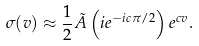Convert formula to latex. <formula><loc_0><loc_0><loc_500><loc_500>\sigma ( v ) \approx \frac { 1 } { 2 } \tilde { A } \left ( i e ^ { - i c \pi / 2 } \right ) e ^ { c v } .</formula> 